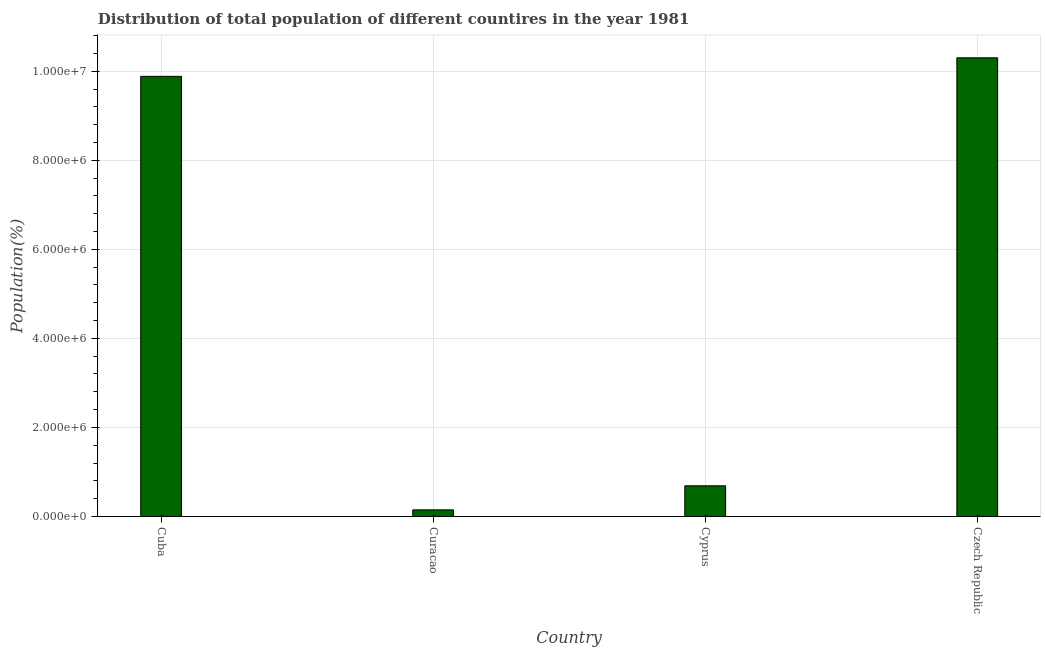Does the graph contain grids?
Keep it short and to the point. Yes. What is the title of the graph?
Keep it short and to the point. Distribution of total population of different countires in the year 1981. What is the label or title of the Y-axis?
Make the answer very short. Population(%). What is the population in Cyprus?
Offer a terse response. 6.89e+05. Across all countries, what is the maximum population?
Provide a succinct answer. 1.03e+07. Across all countries, what is the minimum population?
Make the answer very short. 1.49e+05. In which country was the population maximum?
Offer a terse response. Czech Republic. In which country was the population minimum?
Provide a short and direct response. Curacao. What is the sum of the population?
Ensure brevity in your answer.  2.10e+07. What is the difference between the population in Cuba and Curacao?
Make the answer very short. 9.74e+06. What is the average population per country?
Ensure brevity in your answer.  5.26e+06. What is the median population?
Your answer should be compact. 5.29e+06. In how many countries, is the population greater than 1200000 %?
Your response must be concise. 2. Is the population in Cuba less than that in Cyprus?
Provide a succinct answer. No. Is the difference between the population in Curacao and Czech Republic greater than the difference between any two countries?
Offer a terse response. Yes. What is the difference between the highest and the second highest population?
Ensure brevity in your answer.  4.16e+05. Is the sum of the population in Curacao and Czech Republic greater than the maximum population across all countries?
Your answer should be compact. Yes. What is the difference between the highest and the lowest population?
Make the answer very short. 1.02e+07. How many bars are there?
Provide a succinct answer. 4. What is the difference between two consecutive major ticks on the Y-axis?
Make the answer very short. 2.00e+06. Are the values on the major ticks of Y-axis written in scientific E-notation?
Offer a very short reply. Yes. What is the Population(%) of Cuba?
Offer a terse response. 9.88e+06. What is the Population(%) of Curacao?
Keep it short and to the point. 1.49e+05. What is the Population(%) of Cyprus?
Offer a very short reply. 6.89e+05. What is the Population(%) in Czech Republic?
Keep it short and to the point. 1.03e+07. What is the difference between the Population(%) in Cuba and Curacao?
Make the answer very short. 9.74e+06. What is the difference between the Population(%) in Cuba and Cyprus?
Offer a very short reply. 9.20e+06. What is the difference between the Population(%) in Cuba and Czech Republic?
Give a very brief answer. -4.16e+05. What is the difference between the Population(%) in Curacao and Cyprus?
Your response must be concise. -5.41e+05. What is the difference between the Population(%) in Curacao and Czech Republic?
Your answer should be compact. -1.02e+07. What is the difference between the Population(%) in Cyprus and Czech Republic?
Make the answer very short. -9.61e+06. What is the ratio of the Population(%) in Cuba to that in Curacao?
Make the answer very short. 66.5. What is the ratio of the Population(%) in Cuba to that in Cyprus?
Keep it short and to the point. 14.34. What is the ratio of the Population(%) in Curacao to that in Cyprus?
Provide a succinct answer. 0.22. What is the ratio of the Population(%) in Curacao to that in Czech Republic?
Provide a short and direct response. 0.01. What is the ratio of the Population(%) in Cyprus to that in Czech Republic?
Your response must be concise. 0.07. 